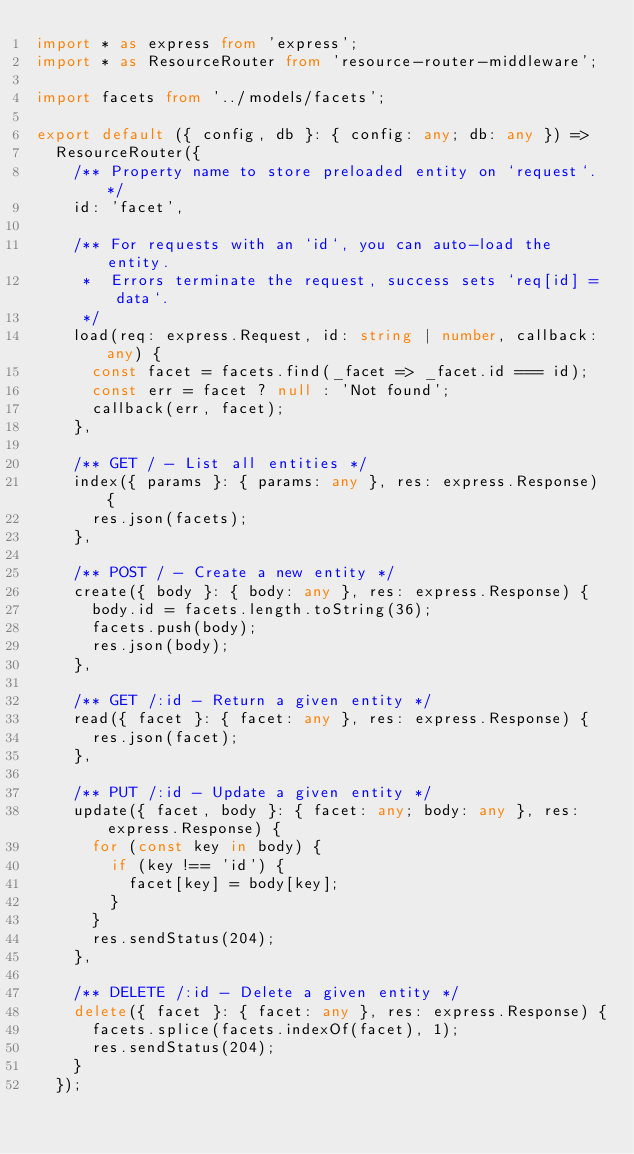<code> <loc_0><loc_0><loc_500><loc_500><_TypeScript_>import * as express from 'express';
import * as ResourceRouter from 'resource-router-middleware';

import facets from '../models/facets';

export default ({ config, db }: { config: any; db: any }) =>
  ResourceRouter({
    /** Property name to store preloaded entity on `request`. */
    id: 'facet',

    /** For requests with an `id`, you can auto-load the entity.
     *  Errors terminate the request, success sets `req[id] = data`.
     */
    load(req: express.Request, id: string | number, callback: any) {
      const facet = facets.find(_facet => _facet.id === id);
      const err = facet ? null : 'Not found';
      callback(err, facet);
    },

    /** GET / - List all entities */
    index({ params }: { params: any }, res: express.Response) {
      res.json(facets);
    },

    /** POST / - Create a new entity */
    create({ body }: { body: any }, res: express.Response) {
      body.id = facets.length.toString(36);
      facets.push(body);
      res.json(body);
    },

    /** GET /:id - Return a given entity */
    read({ facet }: { facet: any }, res: express.Response) {
      res.json(facet);
    },

    /** PUT /:id - Update a given entity */
    update({ facet, body }: { facet: any; body: any }, res: express.Response) {
      for (const key in body) {
        if (key !== 'id') {
          facet[key] = body[key];
        }
      }
      res.sendStatus(204);
    },

    /** DELETE /:id - Delete a given entity */
    delete({ facet }: { facet: any }, res: express.Response) {
      facets.splice(facets.indexOf(facet), 1);
      res.sendStatus(204);
    }
  });
</code> 